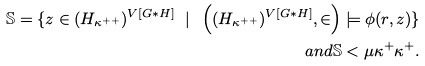Convert formula to latex. <formula><loc_0><loc_0><loc_500><loc_500>\mathbb { S } = \{ z \in ( H _ { \kappa ^ { + + } } ) ^ { V [ G * H ] } \ | \ \left ( ( H _ { \kappa ^ { + + } } ) ^ { V [ G * H ] } , \in \right ) \models \phi ( r , z ) \} \\ a n d \mathbb { S } < \mu \kappa ^ { + } \kappa ^ { + } .</formula> 